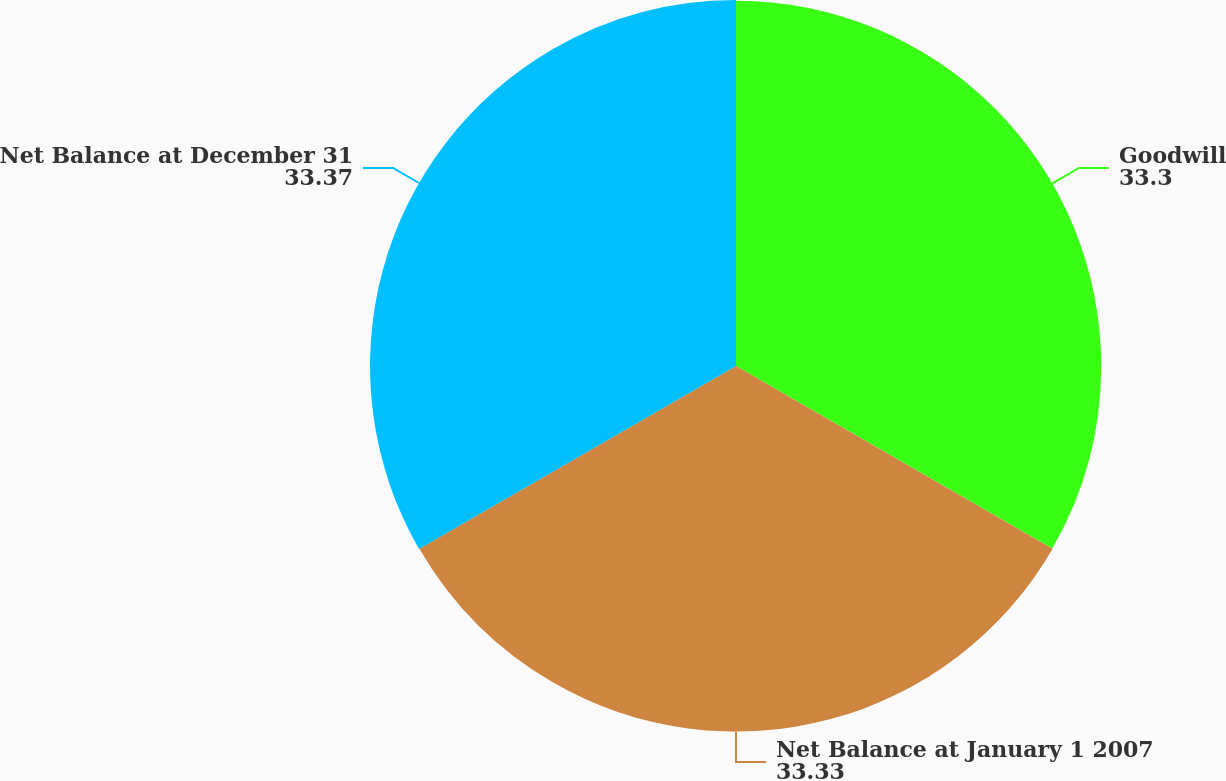Convert chart. <chart><loc_0><loc_0><loc_500><loc_500><pie_chart><fcel>Goodwill<fcel>Net Balance at January 1 2007<fcel>Net Balance at December 31<nl><fcel>33.3%<fcel>33.33%<fcel>33.37%<nl></chart> 